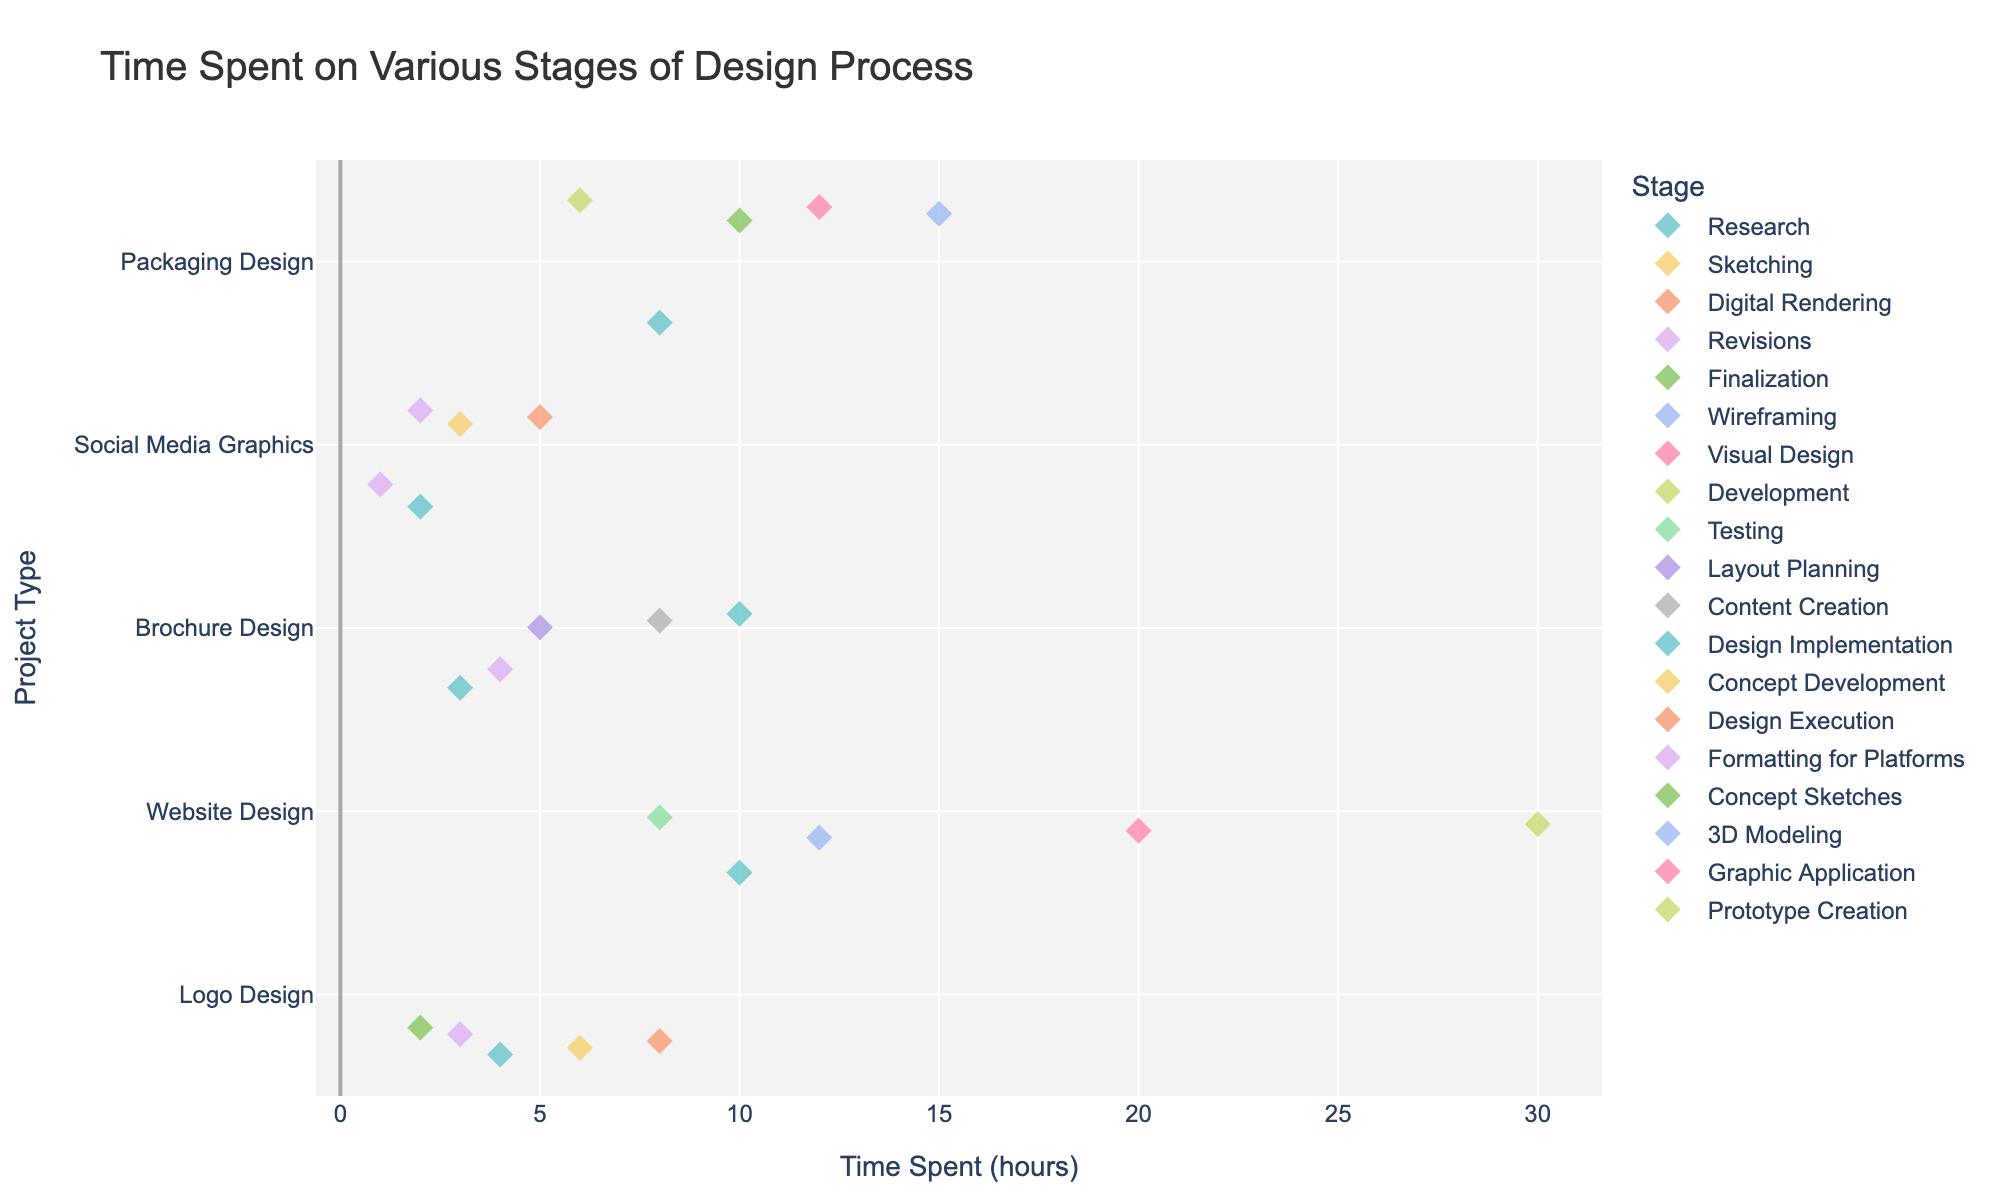What is the title of the plot? The title of the plot provides an overview of what the plot displays. It's found at the top of the figure.
Answer: Time Spent on Various Stages of Design Process Which project type has the highest time spent on any stage? By visually inspecting the plot, you can identify which project type has the highest diamond marker along the x-axis.
Answer: Website Design What is the time spent on the Revisions stage for Brochure Design? You need to identify the "Brochure Design" row and then find the diamond marker colored for the "Revisions" stage. Read the corresponding value on the x-axis.
Answer: 4 hours Which stage of Website Design takes the least amount of time? Locate the "Website Design" row and identify the diamond markers. The one closest to the leftmost side represents the stage with the least time.
Answer: Testing Compare the total time for all stages of Logo Design and Brochure Design. Which one has a higher total time spent? Sum the time spent on each stage for Logo Design and Brochure Design. Logo Design: 4+6+8+3+2 = 23 hours, Brochure Design: 3+5+8+10+4 = 30 hours.
Answer: Brochure Design What is the median time spent across all stages for Packaging Design? List the times for all stages of Packaging Design and find the median value: 8, 10, 15, 12, 6. Ordering these values: 6, 8, 10, 12, 15. The median is the middle value.
Answer: 10 hours Is the time spent on Research the same for all project types? Compare the position of the diamond markers for the "Research" stage across all project types. If their x-axis values match, the time spent is the same.
Answer: No Which stage has the most variation in time spent across different project types? Identify the stage whose diamond markers span the widest range along the x-axis.
Answer: Research If you sum the times spent on the Digital Rendering and Finalization stages of Logo Design, what is the total? Identify the times for Digital Rendering (8 hours) and Finalization (2 hours) stages in Logo Design and sum them up.
Answer: 10 hours What is the difference in time spent on the 3D Modeling stage for Packaging Design compared to the Wireframing stage for Website Design? Locate the times for the 3D Modeling stage (15 hours) and Wireframing stage (12 hours) and calculate the difference.
Answer: 3 hours 